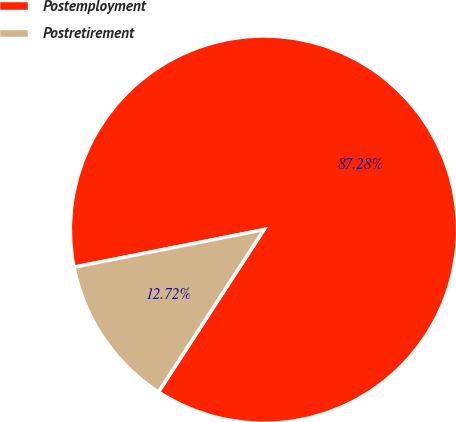Convert chart to OTSL. <chart><loc_0><loc_0><loc_500><loc_500><pie_chart><fcel>Postemployment<fcel>Postretirement<nl><fcel>87.28%<fcel>12.72%<nl></chart> 